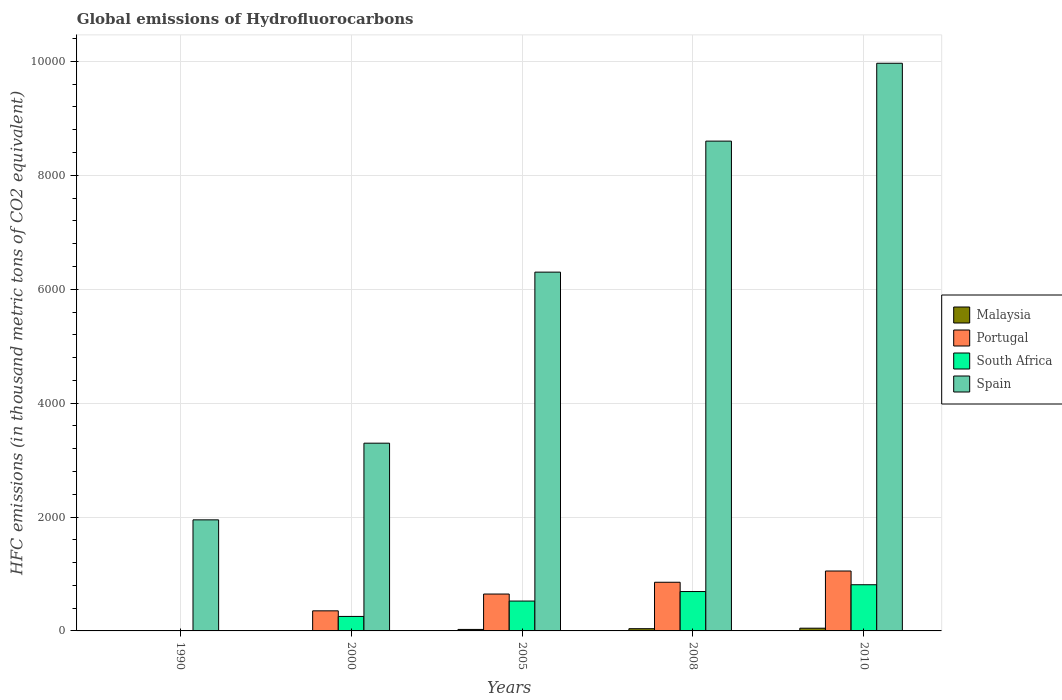Are the number of bars on each tick of the X-axis equal?
Keep it short and to the point. Yes. In how many cases, is the number of bars for a given year not equal to the number of legend labels?
Your answer should be compact. 0. What is the global emissions of Hydrofluorocarbons in Spain in 2008?
Provide a short and direct response. 8600.9. Across all years, what is the maximum global emissions of Hydrofluorocarbons in Portugal?
Your response must be concise. 1052. In which year was the global emissions of Hydrofluorocarbons in Malaysia maximum?
Keep it short and to the point. 2010. What is the total global emissions of Hydrofluorocarbons in South Africa in the graph?
Ensure brevity in your answer.  2281.9. What is the difference between the global emissions of Hydrofluorocarbons in Portugal in 2000 and that in 2005?
Your answer should be compact. -295. What is the difference between the global emissions of Hydrofluorocarbons in Portugal in 2010 and the global emissions of Hydrofluorocarbons in Spain in 2005?
Ensure brevity in your answer.  -5248.3. What is the average global emissions of Hydrofluorocarbons in Portugal per year?
Offer a very short reply. 581.4. In the year 2000, what is the difference between the global emissions of Hydrofluorocarbons in South Africa and global emissions of Hydrofluorocarbons in Spain?
Provide a short and direct response. -3042.2. What is the ratio of the global emissions of Hydrofluorocarbons in Portugal in 1990 to that in 2000?
Offer a terse response. 0. What is the difference between the highest and the second highest global emissions of Hydrofluorocarbons in Malaysia?
Provide a succinct answer. 8.8. What is the difference between the highest and the lowest global emissions of Hydrofluorocarbons in Portugal?
Provide a succinct answer. 1051.8. What does the 1st bar from the left in 2000 represents?
Give a very brief answer. Malaysia. What does the 2nd bar from the right in 2000 represents?
Give a very brief answer. South Africa. Is it the case that in every year, the sum of the global emissions of Hydrofluorocarbons in Malaysia and global emissions of Hydrofluorocarbons in Portugal is greater than the global emissions of Hydrofluorocarbons in South Africa?
Ensure brevity in your answer.  Yes. How many bars are there?
Your answer should be compact. 20. How many years are there in the graph?
Your answer should be very brief. 5. What is the difference between two consecutive major ticks on the Y-axis?
Provide a short and direct response. 2000. Are the values on the major ticks of Y-axis written in scientific E-notation?
Make the answer very short. No. How many legend labels are there?
Offer a terse response. 4. How are the legend labels stacked?
Ensure brevity in your answer.  Vertical. What is the title of the graph?
Keep it short and to the point. Global emissions of Hydrofluorocarbons. Does "Lithuania" appear as one of the legend labels in the graph?
Offer a terse response. No. What is the label or title of the Y-axis?
Provide a succinct answer. HFC emissions (in thousand metric tons of CO2 equivalent). What is the HFC emissions (in thousand metric tons of CO2 equivalent) of Malaysia in 1990?
Your answer should be very brief. 0.1. What is the HFC emissions (in thousand metric tons of CO2 equivalent) in Portugal in 1990?
Provide a short and direct response. 0.2. What is the HFC emissions (in thousand metric tons of CO2 equivalent) in Spain in 1990?
Your response must be concise. 1950.3. What is the HFC emissions (in thousand metric tons of CO2 equivalent) of Malaysia in 2000?
Your response must be concise. 6.9. What is the HFC emissions (in thousand metric tons of CO2 equivalent) in Portugal in 2000?
Keep it short and to the point. 352.7. What is the HFC emissions (in thousand metric tons of CO2 equivalent) in South Africa in 2000?
Make the answer very short. 254.6. What is the HFC emissions (in thousand metric tons of CO2 equivalent) of Spain in 2000?
Provide a short and direct response. 3296.8. What is the HFC emissions (in thousand metric tons of CO2 equivalent) in Malaysia in 2005?
Give a very brief answer. 26.1. What is the HFC emissions (in thousand metric tons of CO2 equivalent) in Portugal in 2005?
Provide a short and direct response. 647.7. What is the HFC emissions (in thousand metric tons of CO2 equivalent) in South Africa in 2005?
Your answer should be compact. 524.5. What is the HFC emissions (in thousand metric tons of CO2 equivalent) in Spain in 2005?
Provide a short and direct response. 6300.3. What is the HFC emissions (in thousand metric tons of CO2 equivalent) in Malaysia in 2008?
Your answer should be compact. 39.2. What is the HFC emissions (in thousand metric tons of CO2 equivalent) of Portugal in 2008?
Offer a terse response. 854.4. What is the HFC emissions (in thousand metric tons of CO2 equivalent) of South Africa in 2008?
Provide a succinct answer. 691.6. What is the HFC emissions (in thousand metric tons of CO2 equivalent) in Spain in 2008?
Your answer should be very brief. 8600.9. What is the HFC emissions (in thousand metric tons of CO2 equivalent) of Portugal in 2010?
Your answer should be compact. 1052. What is the HFC emissions (in thousand metric tons of CO2 equivalent) in South Africa in 2010?
Your response must be concise. 811. What is the HFC emissions (in thousand metric tons of CO2 equivalent) of Spain in 2010?
Your answer should be very brief. 9968. Across all years, what is the maximum HFC emissions (in thousand metric tons of CO2 equivalent) of Malaysia?
Your answer should be compact. 48. Across all years, what is the maximum HFC emissions (in thousand metric tons of CO2 equivalent) in Portugal?
Provide a succinct answer. 1052. Across all years, what is the maximum HFC emissions (in thousand metric tons of CO2 equivalent) of South Africa?
Your response must be concise. 811. Across all years, what is the maximum HFC emissions (in thousand metric tons of CO2 equivalent) in Spain?
Provide a short and direct response. 9968. Across all years, what is the minimum HFC emissions (in thousand metric tons of CO2 equivalent) of Malaysia?
Make the answer very short. 0.1. Across all years, what is the minimum HFC emissions (in thousand metric tons of CO2 equivalent) of Portugal?
Keep it short and to the point. 0.2. Across all years, what is the minimum HFC emissions (in thousand metric tons of CO2 equivalent) in South Africa?
Offer a terse response. 0.2. Across all years, what is the minimum HFC emissions (in thousand metric tons of CO2 equivalent) in Spain?
Keep it short and to the point. 1950.3. What is the total HFC emissions (in thousand metric tons of CO2 equivalent) in Malaysia in the graph?
Provide a short and direct response. 120.3. What is the total HFC emissions (in thousand metric tons of CO2 equivalent) in Portugal in the graph?
Your response must be concise. 2907. What is the total HFC emissions (in thousand metric tons of CO2 equivalent) of South Africa in the graph?
Your response must be concise. 2281.9. What is the total HFC emissions (in thousand metric tons of CO2 equivalent) of Spain in the graph?
Give a very brief answer. 3.01e+04. What is the difference between the HFC emissions (in thousand metric tons of CO2 equivalent) in Malaysia in 1990 and that in 2000?
Provide a short and direct response. -6.8. What is the difference between the HFC emissions (in thousand metric tons of CO2 equivalent) in Portugal in 1990 and that in 2000?
Offer a very short reply. -352.5. What is the difference between the HFC emissions (in thousand metric tons of CO2 equivalent) of South Africa in 1990 and that in 2000?
Offer a very short reply. -254.4. What is the difference between the HFC emissions (in thousand metric tons of CO2 equivalent) in Spain in 1990 and that in 2000?
Offer a very short reply. -1346.5. What is the difference between the HFC emissions (in thousand metric tons of CO2 equivalent) in Malaysia in 1990 and that in 2005?
Give a very brief answer. -26. What is the difference between the HFC emissions (in thousand metric tons of CO2 equivalent) in Portugal in 1990 and that in 2005?
Make the answer very short. -647.5. What is the difference between the HFC emissions (in thousand metric tons of CO2 equivalent) of South Africa in 1990 and that in 2005?
Your answer should be very brief. -524.3. What is the difference between the HFC emissions (in thousand metric tons of CO2 equivalent) in Spain in 1990 and that in 2005?
Offer a very short reply. -4350. What is the difference between the HFC emissions (in thousand metric tons of CO2 equivalent) of Malaysia in 1990 and that in 2008?
Offer a very short reply. -39.1. What is the difference between the HFC emissions (in thousand metric tons of CO2 equivalent) in Portugal in 1990 and that in 2008?
Provide a succinct answer. -854.2. What is the difference between the HFC emissions (in thousand metric tons of CO2 equivalent) in South Africa in 1990 and that in 2008?
Offer a terse response. -691.4. What is the difference between the HFC emissions (in thousand metric tons of CO2 equivalent) of Spain in 1990 and that in 2008?
Offer a very short reply. -6650.6. What is the difference between the HFC emissions (in thousand metric tons of CO2 equivalent) of Malaysia in 1990 and that in 2010?
Ensure brevity in your answer.  -47.9. What is the difference between the HFC emissions (in thousand metric tons of CO2 equivalent) in Portugal in 1990 and that in 2010?
Make the answer very short. -1051.8. What is the difference between the HFC emissions (in thousand metric tons of CO2 equivalent) in South Africa in 1990 and that in 2010?
Keep it short and to the point. -810.8. What is the difference between the HFC emissions (in thousand metric tons of CO2 equivalent) of Spain in 1990 and that in 2010?
Ensure brevity in your answer.  -8017.7. What is the difference between the HFC emissions (in thousand metric tons of CO2 equivalent) of Malaysia in 2000 and that in 2005?
Provide a succinct answer. -19.2. What is the difference between the HFC emissions (in thousand metric tons of CO2 equivalent) in Portugal in 2000 and that in 2005?
Ensure brevity in your answer.  -295. What is the difference between the HFC emissions (in thousand metric tons of CO2 equivalent) of South Africa in 2000 and that in 2005?
Your response must be concise. -269.9. What is the difference between the HFC emissions (in thousand metric tons of CO2 equivalent) of Spain in 2000 and that in 2005?
Provide a succinct answer. -3003.5. What is the difference between the HFC emissions (in thousand metric tons of CO2 equivalent) of Malaysia in 2000 and that in 2008?
Make the answer very short. -32.3. What is the difference between the HFC emissions (in thousand metric tons of CO2 equivalent) of Portugal in 2000 and that in 2008?
Offer a very short reply. -501.7. What is the difference between the HFC emissions (in thousand metric tons of CO2 equivalent) of South Africa in 2000 and that in 2008?
Ensure brevity in your answer.  -437. What is the difference between the HFC emissions (in thousand metric tons of CO2 equivalent) of Spain in 2000 and that in 2008?
Ensure brevity in your answer.  -5304.1. What is the difference between the HFC emissions (in thousand metric tons of CO2 equivalent) of Malaysia in 2000 and that in 2010?
Provide a succinct answer. -41.1. What is the difference between the HFC emissions (in thousand metric tons of CO2 equivalent) of Portugal in 2000 and that in 2010?
Provide a short and direct response. -699.3. What is the difference between the HFC emissions (in thousand metric tons of CO2 equivalent) of South Africa in 2000 and that in 2010?
Provide a short and direct response. -556.4. What is the difference between the HFC emissions (in thousand metric tons of CO2 equivalent) of Spain in 2000 and that in 2010?
Your answer should be compact. -6671.2. What is the difference between the HFC emissions (in thousand metric tons of CO2 equivalent) of Malaysia in 2005 and that in 2008?
Give a very brief answer. -13.1. What is the difference between the HFC emissions (in thousand metric tons of CO2 equivalent) of Portugal in 2005 and that in 2008?
Give a very brief answer. -206.7. What is the difference between the HFC emissions (in thousand metric tons of CO2 equivalent) of South Africa in 2005 and that in 2008?
Provide a short and direct response. -167.1. What is the difference between the HFC emissions (in thousand metric tons of CO2 equivalent) in Spain in 2005 and that in 2008?
Provide a short and direct response. -2300.6. What is the difference between the HFC emissions (in thousand metric tons of CO2 equivalent) of Malaysia in 2005 and that in 2010?
Provide a succinct answer. -21.9. What is the difference between the HFC emissions (in thousand metric tons of CO2 equivalent) of Portugal in 2005 and that in 2010?
Give a very brief answer. -404.3. What is the difference between the HFC emissions (in thousand metric tons of CO2 equivalent) in South Africa in 2005 and that in 2010?
Make the answer very short. -286.5. What is the difference between the HFC emissions (in thousand metric tons of CO2 equivalent) of Spain in 2005 and that in 2010?
Offer a terse response. -3667.7. What is the difference between the HFC emissions (in thousand metric tons of CO2 equivalent) of Malaysia in 2008 and that in 2010?
Ensure brevity in your answer.  -8.8. What is the difference between the HFC emissions (in thousand metric tons of CO2 equivalent) of Portugal in 2008 and that in 2010?
Offer a very short reply. -197.6. What is the difference between the HFC emissions (in thousand metric tons of CO2 equivalent) of South Africa in 2008 and that in 2010?
Your answer should be compact. -119.4. What is the difference between the HFC emissions (in thousand metric tons of CO2 equivalent) of Spain in 2008 and that in 2010?
Provide a succinct answer. -1367.1. What is the difference between the HFC emissions (in thousand metric tons of CO2 equivalent) in Malaysia in 1990 and the HFC emissions (in thousand metric tons of CO2 equivalent) in Portugal in 2000?
Keep it short and to the point. -352.6. What is the difference between the HFC emissions (in thousand metric tons of CO2 equivalent) in Malaysia in 1990 and the HFC emissions (in thousand metric tons of CO2 equivalent) in South Africa in 2000?
Your answer should be compact. -254.5. What is the difference between the HFC emissions (in thousand metric tons of CO2 equivalent) in Malaysia in 1990 and the HFC emissions (in thousand metric tons of CO2 equivalent) in Spain in 2000?
Your answer should be very brief. -3296.7. What is the difference between the HFC emissions (in thousand metric tons of CO2 equivalent) in Portugal in 1990 and the HFC emissions (in thousand metric tons of CO2 equivalent) in South Africa in 2000?
Your response must be concise. -254.4. What is the difference between the HFC emissions (in thousand metric tons of CO2 equivalent) of Portugal in 1990 and the HFC emissions (in thousand metric tons of CO2 equivalent) of Spain in 2000?
Make the answer very short. -3296.6. What is the difference between the HFC emissions (in thousand metric tons of CO2 equivalent) in South Africa in 1990 and the HFC emissions (in thousand metric tons of CO2 equivalent) in Spain in 2000?
Ensure brevity in your answer.  -3296.6. What is the difference between the HFC emissions (in thousand metric tons of CO2 equivalent) of Malaysia in 1990 and the HFC emissions (in thousand metric tons of CO2 equivalent) of Portugal in 2005?
Give a very brief answer. -647.6. What is the difference between the HFC emissions (in thousand metric tons of CO2 equivalent) of Malaysia in 1990 and the HFC emissions (in thousand metric tons of CO2 equivalent) of South Africa in 2005?
Make the answer very short. -524.4. What is the difference between the HFC emissions (in thousand metric tons of CO2 equivalent) in Malaysia in 1990 and the HFC emissions (in thousand metric tons of CO2 equivalent) in Spain in 2005?
Provide a succinct answer. -6300.2. What is the difference between the HFC emissions (in thousand metric tons of CO2 equivalent) of Portugal in 1990 and the HFC emissions (in thousand metric tons of CO2 equivalent) of South Africa in 2005?
Make the answer very short. -524.3. What is the difference between the HFC emissions (in thousand metric tons of CO2 equivalent) in Portugal in 1990 and the HFC emissions (in thousand metric tons of CO2 equivalent) in Spain in 2005?
Ensure brevity in your answer.  -6300.1. What is the difference between the HFC emissions (in thousand metric tons of CO2 equivalent) in South Africa in 1990 and the HFC emissions (in thousand metric tons of CO2 equivalent) in Spain in 2005?
Keep it short and to the point. -6300.1. What is the difference between the HFC emissions (in thousand metric tons of CO2 equivalent) of Malaysia in 1990 and the HFC emissions (in thousand metric tons of CO2 equivalent) of Portugal in 2008?
Ensure brevity in your answer.  -854.3. What is the difference between the HFC emissions (in thousand metric tons of CO2 equivalent) in Malaysia in 1990 and the HFC emissions (in thousand metric tons of CO2 equivalent) in South Africa in 2008?
Provide a succinct answer. -691.5. What is the difference between the HFC emissions (in thousand metric tons of CO2 equivalent) of Malaysia in 1990 and the HFC emissions (in thousand metric tons of CO2 equivalent) of Spain in 2008?
Give a very brief answer. -8600.8. What is the difference between the HFC emissions (in thousand metric tons of CO2 equivalent) of Portugal in 1990 and the HFC emissions (in thousand metric tons of CO2 equivalent) of South Africa in 2008?
Give a very brief answer. -691.4. What is the difference between the HFC emissions (in thousand metric tons of CO2 equivalent) in Portugal in 1990 and the HFC emissions (in thousand metric tons of CO2 equivalent) in Spain in 2008?
Your answer should be compact. -8600.7. What is the difference between the HFC emissions (in thousand metric tons of CO2 equivalent) in South Africa in 1990 and the HFC emissions (in thousand metric tons of CO2 equivalent) in Spain in 2008?
Make the answer very short. -8600.7. What is the difference between the HFC emissions (in thousand metric tons of CO2 equivalent) in Malaysia in 1990 and the HFC emissions (in thousand metric tons of CO2 equivalent) in Portugal in 2010?
Offer a terse response. -1051.9. What is the difference between the HFC emissions (in thousand metric tons of CO2 equivalent) in Malaysia in 1990 and the HFC emissions (in thousand metric tons of CO2 equivalent) in South Africa in 2010?
Provide a succinct answer. -810.9. What is the difference between the HFC emissions (in thousand metric tons of CO2 equivalent) of Malaysia in 1990 and the HFC emissions (in thousand metric tons of CO2 equivalent) of Spain in 2010?
Provide a short and direct response. -9967.9. What is the difference between the HFC emissions (in thousand metric tons of CO2 equivalent) in Portugal in 1990 and the HFC emissions (in thousand metric tons of CO2 equivalent) in South Africa in 2010?
Your answer should be very brief. -810.8. What is the difference between the HFC emissions (in thousand metric tons of CO2 equivalent) in Portugal in 1990 and the HFC emissions (in thousand metric tons of CO2 equivalent) in Spain in 2010?
Ensure brevity in your answer.  -9967.8. What is the difference between the HFC emissions (in thousand metric tons of CO2 equivalent) of South Africa in 1990 and the HFC emissions (in thousand metric tons of CO2 equivalent) of Spain in 2010?
Ensure brevity in your answer.  -9967.8. What is the difference between the HFC emissions (in thousand metric tons of CO2 equivalent) of Malaysia in 2000 and the HFC emissions (in thousand metric tons of CO2 equivalent) of Portugal in 2005?
Give a very brief answer. -640.8. What is the difference between the HFC emissions (in thousand metric tons of CO2 equivalent) in Malaysia in 2000 and the HFC emissions (in thousand metric tons of CO2 equivalent) in South Africa in 2005?
Provide a succinct answer. -517.6. What is the difference between the HFC emissions (in thousand metric tons of CO2 equivalent) in Malaysia in 2000 and the HFC emissions (in thousand metric tons of CO2 equivalent) in Spain in 2005?
Offer a terse response. -6293.4. What is the difference between the HFC emissions (in thousand metric tons of CO2 equivalent) of Portugal in 2000 and the HFC emissions (in thousand metric tons of CO2 equivalent) of South Africa in 2005?
Provide a succinct answer. -171.8. What is the difference between the HFC emissions (in thousand metric tons of CO2 equivalent) in Portugal in 2000 and the HFC emissions (in thousand metric tons of CO2 equivalent) in Spain in 2005?
Your answer should be compact. -5947.6. What is the difference between the HFC emissions (in thousand metric tons of CO2 equivalent) in South Africa in 2000 and the HFC emissions (in thousand metric tons of CO2 equivalent) in Spain in 2005?
Your answer should be very brief. -6045.7. What is the difference between the HFC emissions (in thousand metric tons of CO2 equivalent) in Malaysia in 2000 and the HFC emissions (in thousand metric tons of CO2 equivalent) in Portugal in 2008?
Provide a succinct answer. -847.5. What is the difference between the HFC emissions (in thousand metric tons of CO2 equivalent) of Malaysia in 2000 and the HFC emissions (in thousand metric tons of CO2 equivalent) of South Africa in 2008?
Offer a terse response. -684.7. What is the difference between the HFC emissions (in thousand metric tons of CO2 equivalent) of Malaysia in 2000 and the HFC emissions (in thousand metric tons of CO2 equivalent) of Spain in 2008?
Offer a very short reply. -8594. What is the difference between the HFC emissions (in thousand metric tons of CO2 equivalent) in Portugal in 2000 and the HFC emissions (in thousand metric tons of CO2 equivalent) in South Africa in 2008?
Your response must be concise. -338.9. What is the difference between the HFC emissions (in thousand metric tons of CO2 equivalent) in Portugal in 2000 and the HFC emissions (in thousand metric tons of CO2 equivalent) in Spain in 2008?
Offer a terse response. -8248.2. What is the difference between the HFC emissions (in thousand metric tons of CO2 equivalent) of South Africa in 2000 and the HFC emissions (in thousand metric tons of CO2 equivalent) of Spain in 2008?
Offer a very short reply. -8346.3. What is the difference between the HFC emissions (in thousand metric tons of CO2 equivalent) of Malaysia in 2000 and the HFC emissions (in thousand metric tons of CO2 equivalent) of Portugal in 2010?
Ensure brevity in your answer.  -1045.1. What is the difference between the HFC emissions (in thousand metric tons of CO2 equivalent) of Malaysia in 2000 and the HFC emissions (in thousand metric tons of CO2 equivalent) of South Africa in 2010?
Make the answer very short. -804.1. What is the difference between the HFC emissions (in thousand metric tons of CO2 equivalent) in Malaysia in 2000 and the HFC emissions (in thousand metric tons of CO2 equivalent) in Spain in 2010?
Your answer should be very brief. -9961.1. What is the difference between the HFC emissions (in thousand metric tons of CO2 equivalent) of Portugal in 2000 and the HFC emissions (in thousand metric tons of CO2 equivalent) of South Africa in 2010?
Give a very brief answer. -458.3. What is the difference between the HFC emissions (in thousand metric tons of CO2 equivalent) in Portugal in 2000 and the HFC emissions (in thousand metric tons of CO2 equivalent) in Spain in 2010?
Give a very brief answer. -9615.3. What is the difference between the HFC emissions (in thousand metric tons of CO2 equivalent) in South Africa in 2000 and the HFC emissions (in thousand metric tons of CO2 equivalent) in Spain in 2010?
Keep it short and to the point. -9713.4. What is the difference between the HFC emissions (in thousand metric tons of CO2 equivalent) in Malaysia in 2005 and the HFC emissions (in thousand metric tons of CO2 equivalent) in Portugal in 2008?
Your response must be concise. -828.3. What is the difference between the HFC emissions (in thousand metric tons of CO2 equivalent) of Malaysia in 2005 and the HFC emissions (in thousand metric tons of CO2 equivalent) of South Africa in 2008?
Give a very brief answer. -665.5. What is the difference between the HFC emissions (in thousand metric tons of CO2 equivalent) of Malaysia in 2005 and the HFC emissions (in thousand metric tons of CO2 equivalent) of Spain in 2008?
Make the answer very short. -8574.8. What is the difference between the HFC emissions (in thousand metric tons of CO2 equivalent) of Portugal in 2005 and the HFC emissions (in thousand metric tons of CO2 equivalent) of South Africa in 2008?
Keep it short and to the point. -43.9. What is the difference between the HFC emissions (in thousand metric tons of CO2 equivalent) in Portugal in 2005 and the HFC emissions (in thousand metric tons of CO2 equivalent) in Spain in 2008?
Your answer should be compact. -7953.2. What is the difference between the HFC emissions (in thousand metric tons of CO2 equivalent) in South Africa in 2005 and the HFC emissions (in thousand metric tons of CO2 equivalent) in Spain in 2008?
Provide a short and direct response. -8076.4. What is the difference between the HFC emissions (in thousand metric tons of CO2 equivalent) of Malaysia in 2005 and the HFC emissions (in thousand metric tons of CO2 equivalent) of Portugal in 2010?
Provide a short and direct response. -1025.9. What is the difference between the HFC emissions (in thousand metric tons of CO2 equivalent) in Malaysia in 2005 and the HFC emissions (in thousand metric tons of CO2 equivalent) in South Africa in 2010?
Provide a short and direct response. -784.9. What is the difference between the HFC emissions (in thousand metric tons of CO2 equivalent) of Malaysia in 2005 and the HFC emissions (in thousand metric tons of CO2 equivalent) of Spain in 2010?
Give a very brief answer. -9941.9. What is the difference between the HFC emissions (in thousand metric tons of CO2 equivalent) in Portugal in 2005 and the HFC emissions (in thousand metric tons of CO2 equivalent) in South Africa in 2010?
Give a very brief answer. -163.3. What is the difference between the HFC emissions (in thousand metric tons of CO2 equivalent) in Portugal in 2005 and the HFC emissions (in thousand metric tons of CO2 equivalent) in Spain in 2010?
Keep it short and to the point. -9320.3. What is the difference between the HFC emissions (in thousand metric tons of CO2 equivalent) of South Africa in 2005 and the HFC emissions (in thousand metric tons of CO2 equivalent) of Spain in 2010?
Ensure brevity in your answer.  -9443.5. What is the difference between the HFC emissions (in thousand metric tons of CO2 equivalent) in Malaysia in 2008 and the HFC emissions (in thousand metric tons of CO2 equivalent) in Portugal in 2010?
Your response must be concise. -1012.8. What is the difference between the HFC emissions (in thousand metric tons of CO2 equivalent) in Malaysia in 2008 and the HFC emissions (in thousand metric tons of CO2 equivalent) in South Africa in 2010?
Provide a succinct answer. -771.8. What is the difference between the HFC emissions (in thousand metric tons of CO2 equivalent) of Malaysia in 2008 and the HFC emissions (in thousand metric tons of CO2 equivalent) of Spain in 2010?
Provide a succinct answer. -9928.8. What is the difference between the HFC emissions (in thousand metric tons of CO2 equivalent) in Portugal in 2008 and the HFC emissions (in thousand metric tons of CO2 equivalent) in South Africa in 2010?
Provide a succinct answer. 43.4. What is the difference between the HFC emissions (in thousand metric tons of CO2 equivalent) in Portugal in 2008 and the HFC emissions (in thousand metric tons of CO2 equivalent) in Spain in 2010?
Provide a succinct answer. -9113.6. What is the difference between the HFC emissions (in thousand metric tons of CO2 equivalent) in South Africa in 2008 and the HFC emissions (in thousand metric tons of CO2 equivalent) in Spain in 2010?
Your response must be concise. -9276.4. What is the average HFC emissions (in thousand metric tons of CO2 equivalent) in Malaysia per year?
Give a very brief answer. 24.06. What is the average HFC emissions (in thousand metric tons of CO2 equivalent) of Portugal per year?
Provide a succinct answer. 581.4. What is the average HFC emissions (in thousand metric tons of CO2 equivalent) of South Africa per year?
Ensure brevity in your answer.  456.38. What is the average HFC emissions (in thousand metric tons of CO2 equivalent) of Spain per year?
Ensure brevity in your answer.  6023.26. In the year 1990, what is the difference between the HFC emissions (in thousand metric tons of CO2 equivalent) in Malaysia and HFC emissions (in thousand metric tons of CO2 equivalent) in Portugal?
Your answer should be compact. -0.1. In the year 1990, what is the difference between the HFC emissions (in thousand metric tons of CO2 equivalent) of Malaysia and HFC emissions (in thousand metric tons of CO2 equivalent) of Spain?
Your answer should be very brief. -1950.2. In the year 1990, what is the difference between the HFC emissions (in thousand metric tons of CO2 equivalent) of Portugal and HFC emissions (in thousand metric tons of CO2 equivalent) of Spain?
Give a very brief answer. -1950.1. In the year 1990, what is the difference between the HFC emissions (in thousand metric tons of CO2 equivalent) of South Africa and HFC emissions (in thousand metric tons of CO2 equivalent) of Spain?
Make the answer very short. -1950.1. In the year 2000, what is the difference between the HFC emissions (in thousand metric tons of CO2 equivalent) of Malaysia and HFC emissions (in thousand metric tons of CO2 equivalent) of Portugal?
Offer a terse response. -345.8. In the year 2000, what is the difference between the HFC emissions (in thousand metric tons of CO2 equivalent) of Malaysia and HFC emissions (in thousand metric tons of CO2 equivalent) of South Africa?
Ensure brevity in your answer.  -247.7. In the year 2000, what is the difference between the HFC emissions (in thousand metric tons of CO2 equivalent) in Malaysia and HFC emissions (in thousand metric tons of CO2 equivalent) in Spain?
Your answer should be compact. -3289.9. In the year 2000, what is the difference between the HFC emissions (in thousand metric tons of CO2 equivalent) in Portugal and HFC emissions (in thousand metric tons of CO2 equivalent) in South Africa?
Provide a succinct answer. 98.1. In the year 2000, what is the difference between the HFC emissions (in thousand metric tons of CO2 equivalent) in Portugal and HFC emissions (in thousand metric tons of CO2 equivalent) in Spain?
Your answer should be compact. -2944.1. In the year 2000, what is the difference between the HFC emissions (in thousand metric tons of CO2 equivalent) of South Africa and HFC emissions (in thousand metric tons of CO2 equivalent) of Spain?
Offer a terse response. -3042.2. In the year 2005, what is the difference between the HFC emissions (in thousand metric tons of CO2 equivalent) of Malaysia and HFC emissions (in thousand metric tons of CO2 equivalent) of Portugal?
Keep it short and to the point. -621.6. In the year 2005, what is the difference between the HFC emissions (in thousand metric tons of CO2 equivalent) in Malaysia and HFC emissions (in thousand metric tons of CO2 equivalent) in South Africa?
Provide a short and direct response. -498.4. In the year 2005, what is the difference between the HFC emissions (in thousand metric tons of CO2 equivalent) in Malaysia and HFC emissions (in thousand metric tons of CO2 equivalent) in Spain?
Offer a terse response. -6274.2. In the year 2005, what is the difference between the HFC emissions (in thousand metric tons of CO2 equivalent) of Portugal and HFC emissions (in thousand metric tons of CO2 equivalent) of South Africa?
Your answer should be compact. 123.2. In the year 2005, what is the difference between the HFC emissions (in thousand metric tons of CO2 equivalent) of Portugal and HFC emissions (in thousand metric tons of CO2 equivalent) of Spain?
Your answer should be very brief. -5652.6. In the year 2005, what is the difference between the HFC emissions (in thousand metric tons of CO2 equivalent) in South Africa and HFC emissions (in thousand metric tons of CO2 equivalent) in Spain?
Give a very brief answer. -5775.8. In the year 2008, what is the difference between the HFC emissions (in thousand metric tons of CO2 equivalent) of Malaysia and HFC emissions (in thousand metric tons of CO2 equivalent) of Portugal?
Make the answer very short. -815.2. In the year 2008, what is the difference between the HFC emissions (in thousand metric tons of CO2 equivalent) in Malaysia and HFC emissions (in thousand metric tons of CO2 equivalent) in South Africa?
Your response must be concise. -652.4. In the year 2008, what is the difference between the HFC emissions (in thousand metric tons of CO2 equivalent) in Malaysia and HFC emissions (in thousand metric tons of CO2 equivalent) in Spain?
Ensure brevity in your answer.  -8561.7. In the year 2008, what is the difference between the HFC emissions (in thousand metric tons of CO2 equivalent) in Portugal and HFC emissions (in thousand metric tons of CO2 equivalent) in South Africa?
Keep it short and to the point. 162.8. In the year 2008, what is the difference between the HFC emissions (in thousand metric tons of CO2 equivalent) of Portugal and HFC emissions (in thousand metric tons of CO2 equivalent) of Spain?
Provide a succinct answer. -7746.5. In the year 2008, what is the difference between the HFC emissions (in thousand metric tons of CO2 equivalent) in South Africa and HFC emissions (in thousand metric tons of CO2 equivalent) in Spain?
Give a very brief answer. -7909.3. In the year 2010, what is the difference between the HFC emissions (in thousand metric tons of CO2 equivalent) of Malaysia and HFC emissions (in thousand metric tons of CO2 equivalent) of Portugal?
Offer a terse response. -1004. In the year 2010, what is the difference between the HFC emissions (in thousand metric tons of CO2 equivalent) in Malaysia and HFC emissions (in thousand metric tons of CO2 equivalent) in South Africa?
Offer a terse response. -763. In the year 2010, what is the difference between the HFC emissions (in thousand metric tons of CO2 equivalent) of Malaysia and HFC emissions (in thousand metric tons of CO2 equivalent) of Spain?
Make the answer very short. -9920. In the year 2010, what is the difference between the HFC emissions (in thousand metric tons of CO2 equivalent) of Portugal and HFC emissions (in thousand metric tons of CO2 equivalent) of South Africa?
Offer a very short reply. 241. In the year 2010, what is the difference between the HFC emissions (in thousand metric tons of CO2 equivalent) in Portugal and HFC emissions (in thousand metric tons of CO2 equivalent) in Spain?
Your answer should be compact. -8916. In the year 2010, what is the difference between the HFC emissions (in thousand metric tons of CO2 equivalent) in South Africa and HFC emissions (in thousand metric tons of CO2 equivalent) in Spain?
Provide a short and direct response. -9157. What is the ratio of the HFC emissions (in thousand metric tons of CO2 equivalent) of Malaysia in 1990 to that in 2000?
Your answer should be very brief. 0.01. What is the ratio of the HFC emissions (in thousand metric tons of CO2 equivalent) of Portugal in 1990 to that in 2000?
Offer a very short reply. 0. What is the ratio of the HFC emissions (in thousand metric tons of CO2 equivalent) in South Africa in 1990 to that in 2000?
Your answer should be very brief. 0. What is the ratio of the HFC emissions (in thousand metric tons of CO2 equivalent) of Spain in 1990 to that in 2000?
Provide a succinct answer. 0.59. What is the ratio of the HFC emissions (in thousand metric tons of CO2 equivalent) of Malaysia in 1990 to that in 2005?
Your response must be concise. 0. What is the ratio of the HFC emissions (in thousand metric tons of CO2 equivalent) of Portugal in 1990 to that in 2005?
Your answer should be compact. 0. What is the ratio of the HFC emissions (in thousand metric tons of CO2 equivalent) of Spain in 1990 to that in 2005?
Offer a terse response. 0.31. What is the ratio of the HFC emissions (in thousand metric tons of CO2 equivalent) in Malaysia in 1990 to that in 2008?
Your response must be concise. 0. What is the ratio of the HFC emissions (in thousand metric tons of CO2 equivalent) of Spain in 1990 to that in 2008?
Provide a short and direct response. 0.23. What is the ratio of the HFC emissions (in thousand metric tons of CO2 equivalent) of Malaysia in 1990 to that in 2010?
Ensure brevity in your answer.  0. What is the ratio of the HFC emissions (in thousand metric tons of CO2 equivalent) in Spain in 1990 to that in 2010?
Your answer should be compact. 0.2. What is the ratio of the HFC emissions (in thousand metric tons of CO2 equivalent) of Malaysia in 2000 to that in 2005?
Your answer should be compact. 0.26. What is the ratio of the HFC emissions (in thousand metric tons of CO2 equivalent) of Portugal in 2000 to that in 2005?
Provide a short and direct response. 0.54. What is the ratio of the HFC emissions (in thousand metric tons of CO2 equivalent) in South Africa in 2000 to that in 2005?
Your answer should be very brief. 0.49. What is the ratio of the HFC emissions (in thousand metric tons of CO2 equivalent) in Spain in 2000 to that in 2005?
Provide a short and direct response. 0.52. What is the ratio of the HFC emissions (in thousand metric tons of CO2 equivalent) in Malaysia in 2000 to that in 2008?
Your answer should be very brief. 0.18. What is the ratio of the HFC emissions (in thousand metric tons of CO2 equivalent) in Portugal in 2000 to that in 2008?
Offer a very short reply. 0.41. What is the ratio of the HFC emissions (in thousand metric tons of CO2 equivalent) of South Africa in 2000 to that in 2008?
Offer a terse response. 0.37. What is the ratio of the HFC emissions (in thousand metric tons of CO2 equivalent) in Spain in 2000 to that in 2008?
Your response must be concise. 0.38. What is the ratio of the HFC emissions (in thousand metric tons of CO2 equivalent) in Malaysia in 2000 to that in 2010?
Give a very brief answer. 0.14. What is the ratio of the HFC emissions (in thousand metric tons of CO2 equivalent) of Portugal in 2000 to that in 2010?
Your answer should be compact. 0.34. What is the ratio of the HFC emissions (in thousand metric tons of CO2 equivalent) in South Africa in 2000 to that in 2010?
Ensure brevity in your answer.  0.31. What is the ratio of the HFC emissions (in thousand metric tons of CO2 equivalent) of Spain in 2000 to that in 2010?
Your answer should be compact. 0.33. What is the ratio of the HFC emissions (in thousand metric tons of CO2 equivalent) in Malaysia in 2005 to that in 2008?
Make the answer very short. 0.67. What is the ratio of the HFC emissions (in thousand metric tons of CO2 equivalent) in Portugal in 2005 to that in 2008?
Ensure brevity in your answer.  0.76. What is the ratio of the HFC emissions (in thousand metric tons of CO2 equivalent) in South Africa in 2005 to that in 2008?
Your answer should be compact. 0.76. What is the ratio of the HFC emissions (in thousand metric tons of CO2 equivalent) of Spain in 2005 to that in 2008?
Make the answer very short. 0.73. What is the ratio of the HFC emissions (in thousand metric tons of CO2 equivalent) in Malaysia in 2005 to that in 2010?
Give a very brief answer. 0.54. What is the ratio of the HFC emissions (in thousand metric tons of CO2 equivalent) in Portugal in 2005 to that in 2010?
Give a very brief answer. 0.62. What is the ratio of the HFC emissions (in thousand metric tons of CO2 equivalent) of South Africa in 2005 to that in 2010?
Make the answer very short. 0.65. What is the ratio of the HFC emissions (in thousand metric tons of CO2 equivalent) of Spain in 2005 to that in 2010?
Your answer should be very brief. 0.63. What is the ratio of the HFC emissions (in thousand metric tons of CO2 equivalent) in Malaysia in 2008 to that in 2010?
Provide a succinct answer. 0.82. What is the ratio of the HFC emissions (in thousand metric tons of CO2 equivalent) of Portugal in 2008 to that in 2010?
Provide a short and direct response. 0.81. What is the ratio of the HFC emissions (in thousand metric tons of CO2 equivalent) in South Africa in 2008 to that in 2010?
Offer a terse response. 0.85. What is the ratio of the HFC emissions (in thousand metric tons of CO2 equivalent) of Spain in 2008 to that in 2010?
Offer a very short reply. 0.86. What is the difference between the highest and the second highest HFC emissions (in thousand metric tons of CO2 equivalent) of Portugal?
Make the answer very short. 197.6. What is the difference between the highest and the second highest HFC emissions (in thousand metric tons of CO2 equivalent) of South Africa?
Ensure brevity in your answer.  119.4. What is the difference between the highest and the second highest HFC emissions (in thousand metric tons of CO2 equivalent) in Spain?
Your answer should be compact. 1367.1. What is the difference between the highest and the lowest HFC emissions (in thousand metric tons of CO2 equivalent) in Malaysia?
Your answer should be compact. 47.9. What is the difference between the highest and the lowest HFC emissions (in thousand metric tons of CO2 equivalent) in Portugal?
Make the answer very short. 1051.8. What is the difference between the highest and the lowest HFC emissions (in thousand metric tons of CO2 equivalent) in South Africa?
Offer a terse response. 810.8. What is the difference between the highest and the lowest HFC emissions (in thousand metric tons of CO2 equivalent) of Spain?
Your answer should be compact. 8017.7. 